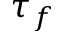Convert formula to latex. <formula><loc_0><loc_0><loc_500><loc_500>\tau _ { f }</formula> 